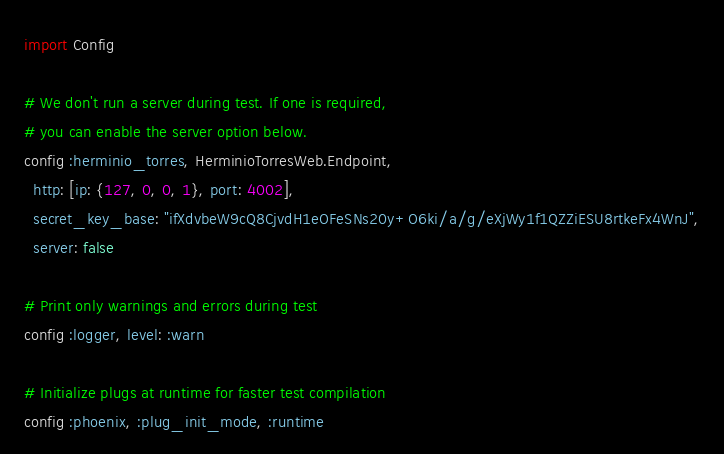<code> <loc_0><loc_0><loc_500><loc_500><_Elixir_>import Config

# We don't run a server during test. If one is required,
# you can enable the server option below.
config :herminio_torres, HerminioTorresWeb.Endpoint,
  http: [ip: {127, 0, 0, 1}, port: 4002],
  secret_key_base: "ifXdvbeW9cQ8CjvdH1eOFeSNs20y+O6ki/a/g/eXjWy1f1QZZiESU8rtkeFx4WnJ",
  server: false

# Print only warnings and errors during test
config :logger, level: :warn

# Initialize plugs at runtime for faster test compilation
config :phoenix, :plug_init_mode, :runtime
</code> 